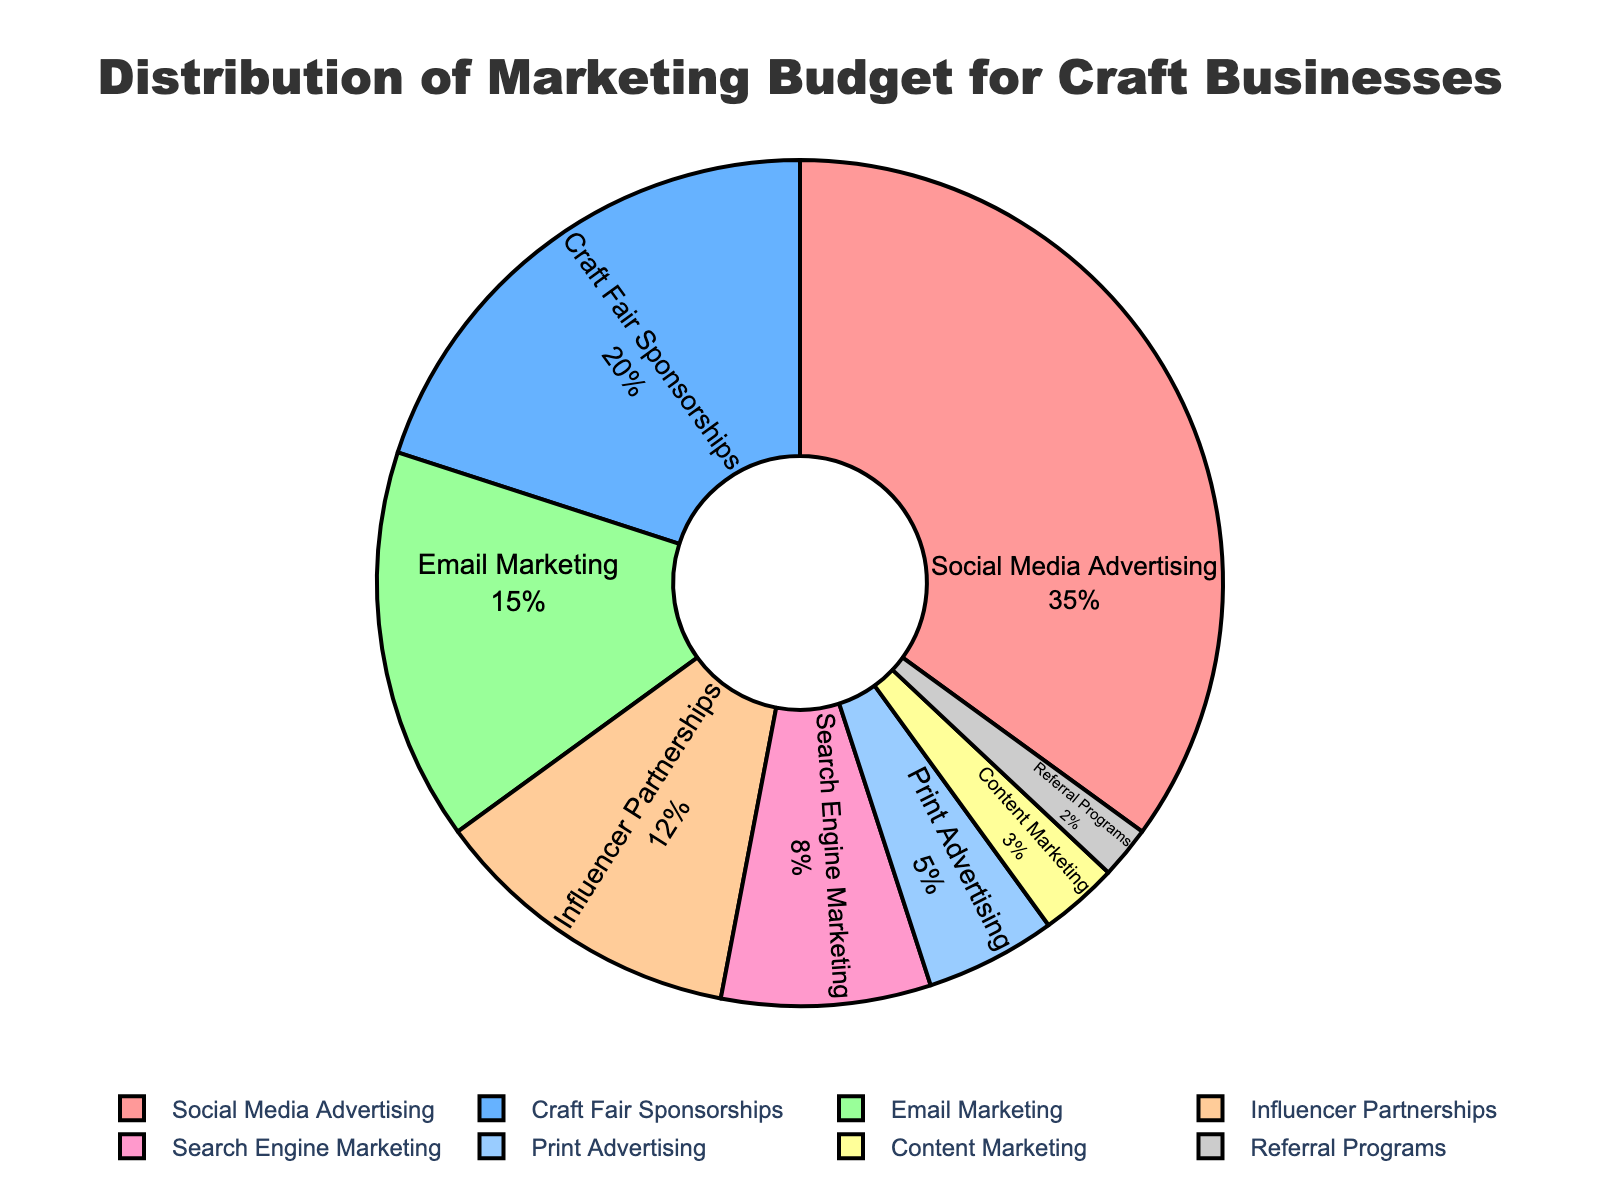Which channel has the highest percentage of the marketing budget? From the figure, the largest segment of the pie chart represents "Social Media Advertising" with 35%.
Answer: Social Media Advertising Which channel allocates the least amount of the marketing budget? By inspecting the smallest slice of the pie chart, "Referral Programs" only has 2%.
Answer: Referral Programs What is the total percentage allocated to Search Engine Marketing and Print Advertising combined? Search Engine Marketing is 8% and Print Advertising is 5%. Adding these, 8% + 5% = 13%.
Answer: 13% How much more percentage of the marketing budget is spent on Social Media Advertising compared to Email Marketing? Social Media Advertising has 35% and Email Marketing has 15%. The difference is 35% - 15% = 20%.
Answer: 20% Which channels together allocate a total of 50% of the marketing budget? Social Media Advertising (35%) plus Craft Fair Sponsorships (20%) exceed 50%. However, Social Media Advertising (35%) plus Email Marketing (15%) exactly equal 50%.
Answer: Social Media Advertising and Email Marketing Between Influencer Partnerships and Content Marketing, which channel has a larger percentage and by how much? Influencer Partnerships is 12% and Content Marketing is 3%. The difference is 12% - 3% = 9%.
Answer: Influencer Partnerships by 9% What is the difference in percentage allocation between the channels with the second highest and second lowest percentages? Craft Fair Sponsorships has 20% (second highest) and Referral Programs has 2% (second lowest). The difference is 20% - 2% = 18%.
Answer: 18% What is the combined percentage of the three smallest allocations? Content Marketing (3%), Referral Programs (2%), and Print Advertising (5%). The total is 3% + 2% + 5% = 10%.
Answer: 10% Which color represents Email Marketing in the pie chart? Observe the color associated with the Email Marketing label in the chart. It is green.
Answer: green If Social Media Advertising budget were equally divided with Craft Fair Sponsorships, what would be the new percentage for each? Social Media Advertising (35%) and Craft Fair Sponsorships (20%) combined is 55%. Dividing 55% by 2 gives each 27.5%.
Answer: 27.5% each 